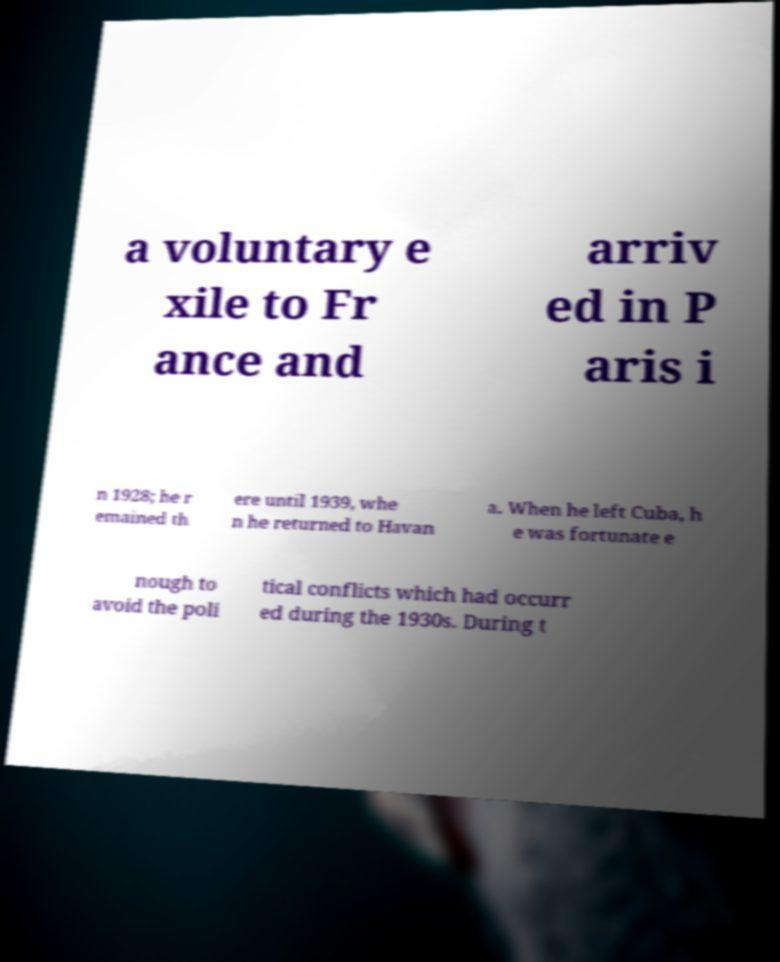There's text embedded in this image that I need extracted. Can you transcribe it verbatim? a voluntary e xile to Fr ance and arriv ed in P aris i n 1928; he r emained th ere until 1939, whe n he returned to Havan a. When he left Cuba, h e was fortunate e nough to avoid the poli tical conflicts which had occurr ed during the 1930s. During t 